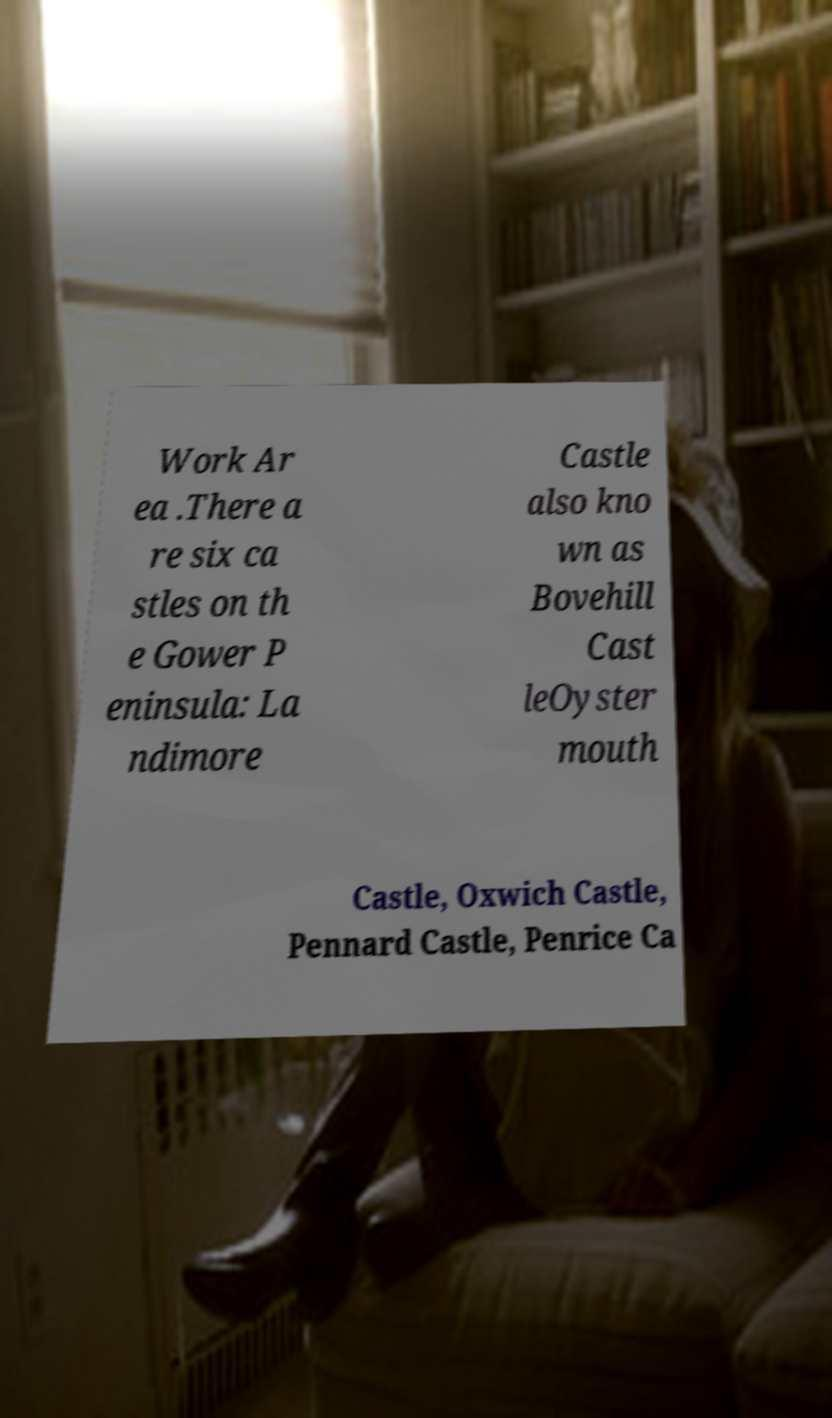There's text embedded in this image that I need extracted. Can you transcribe it verbatim? Work Ar ea .There a re six ca stles on th e Gower P eninsula: La ndimore Castle also kno wn as Bovehill Cast leOyster mouth Castle, Oxwich Castle, Pennard Castle, Penrice Ca 